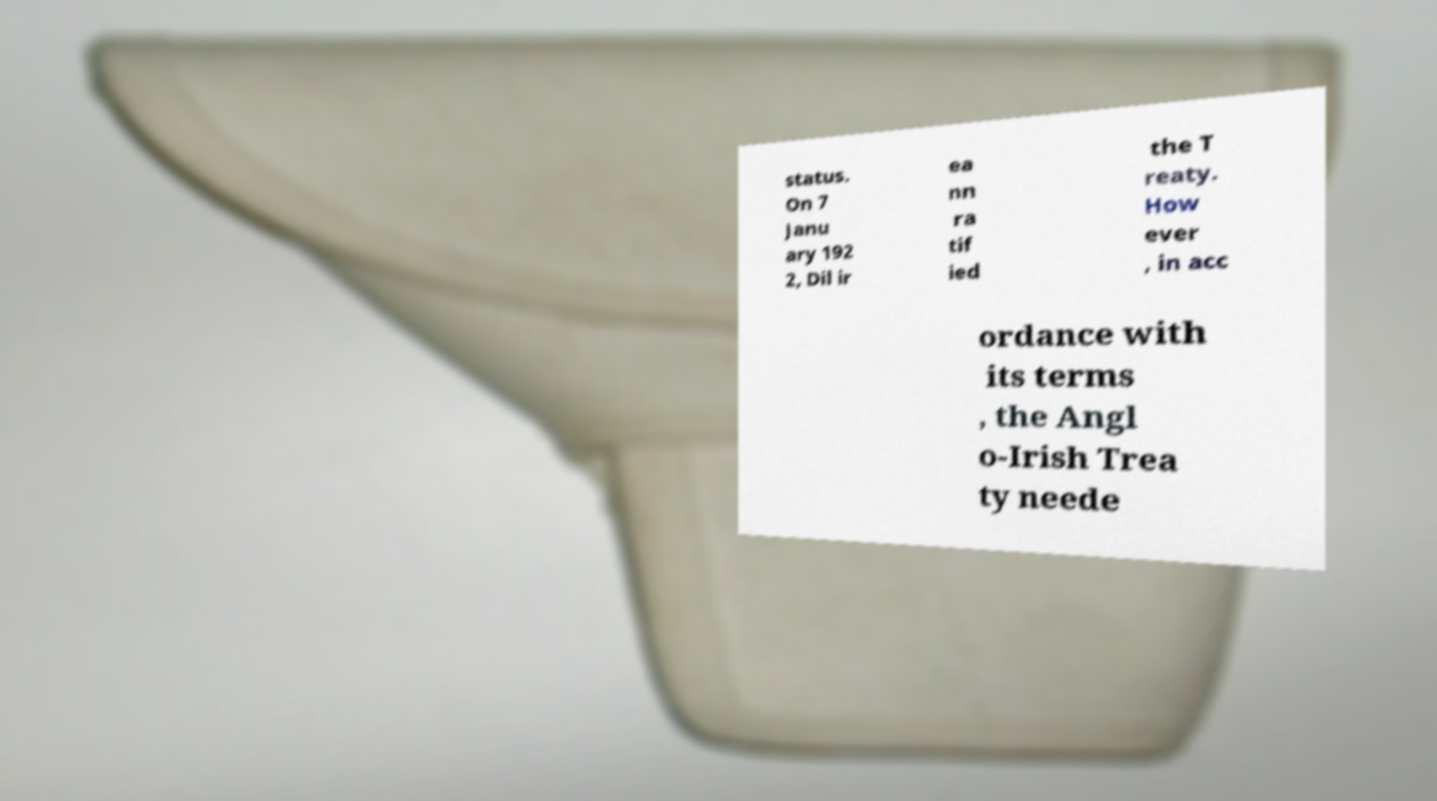There's text embedded in this image that I need extracted. Can you transcribe it verbatim? status. On 7 Janu ary 192 2, Dil ir ea nn ra tif ied the T reaty. How ever , in acc ordance with its terms , the Angl o-Irish Trea ty neede 